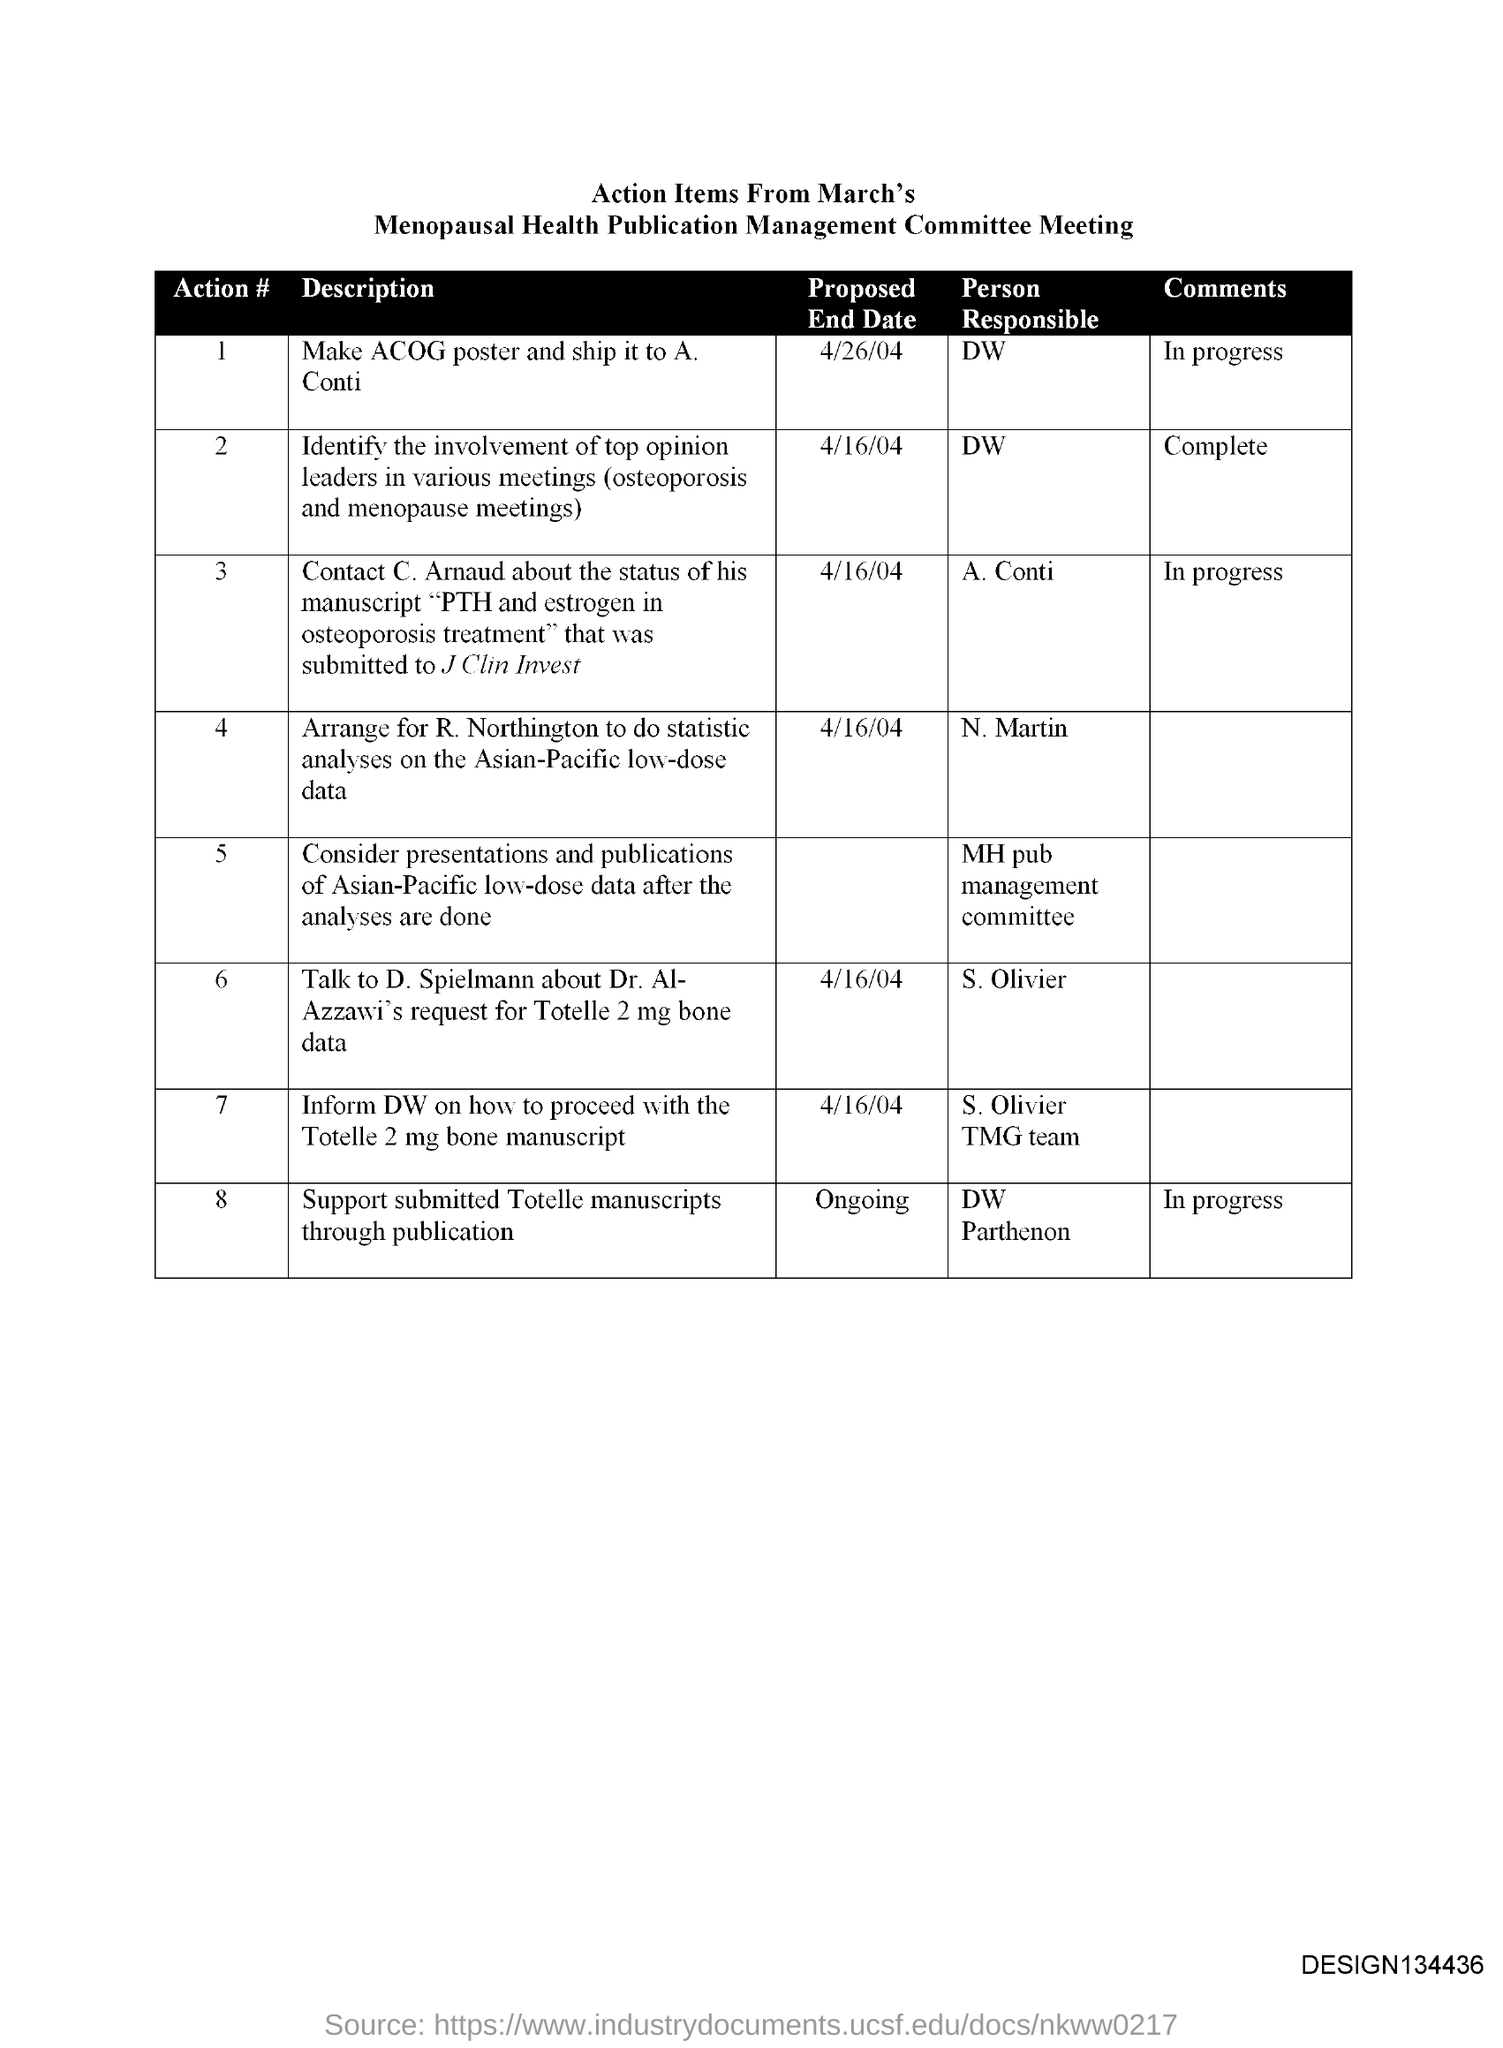Identify some key points in this picture. The person responsible for Action #1 is DW. 